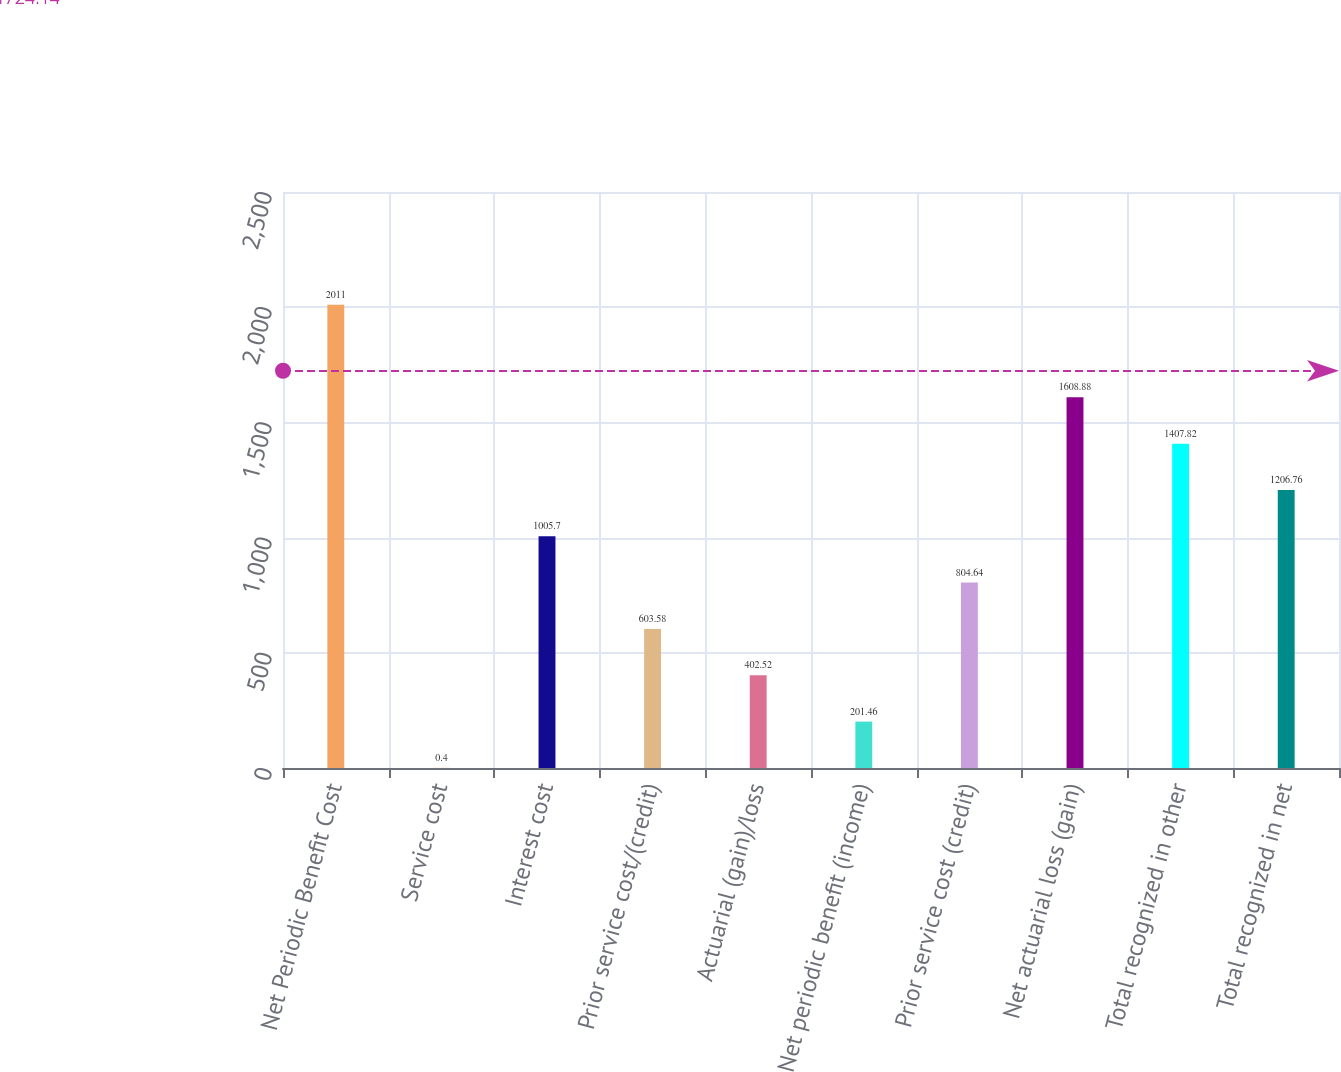Convert chart. <chart><loc_0><loc_0><loc_500><loc_500><bar_chart><fcel>Net Periodic Benefit Cost<fcel>Service cost<fcel>Interest cost<fcel>Prior service cost/(credit)<fcel>Actuarial (gain)/loss<fcel>Net periodic benefit (income)<fcel>Prior service cost (credit)<fcel>Net actuarial loss (gain)<fcel>Total recognized in other<fcel>Total recognized in net<nl><fcel>2011<fcel>0.4<fcel>1005.7<fcel>603.58<fcel>402.52<fcel>201.46<fcel>804.64<fcel>1608.88<fcel>1407.82<fcel>1206.76<nl></chart> 